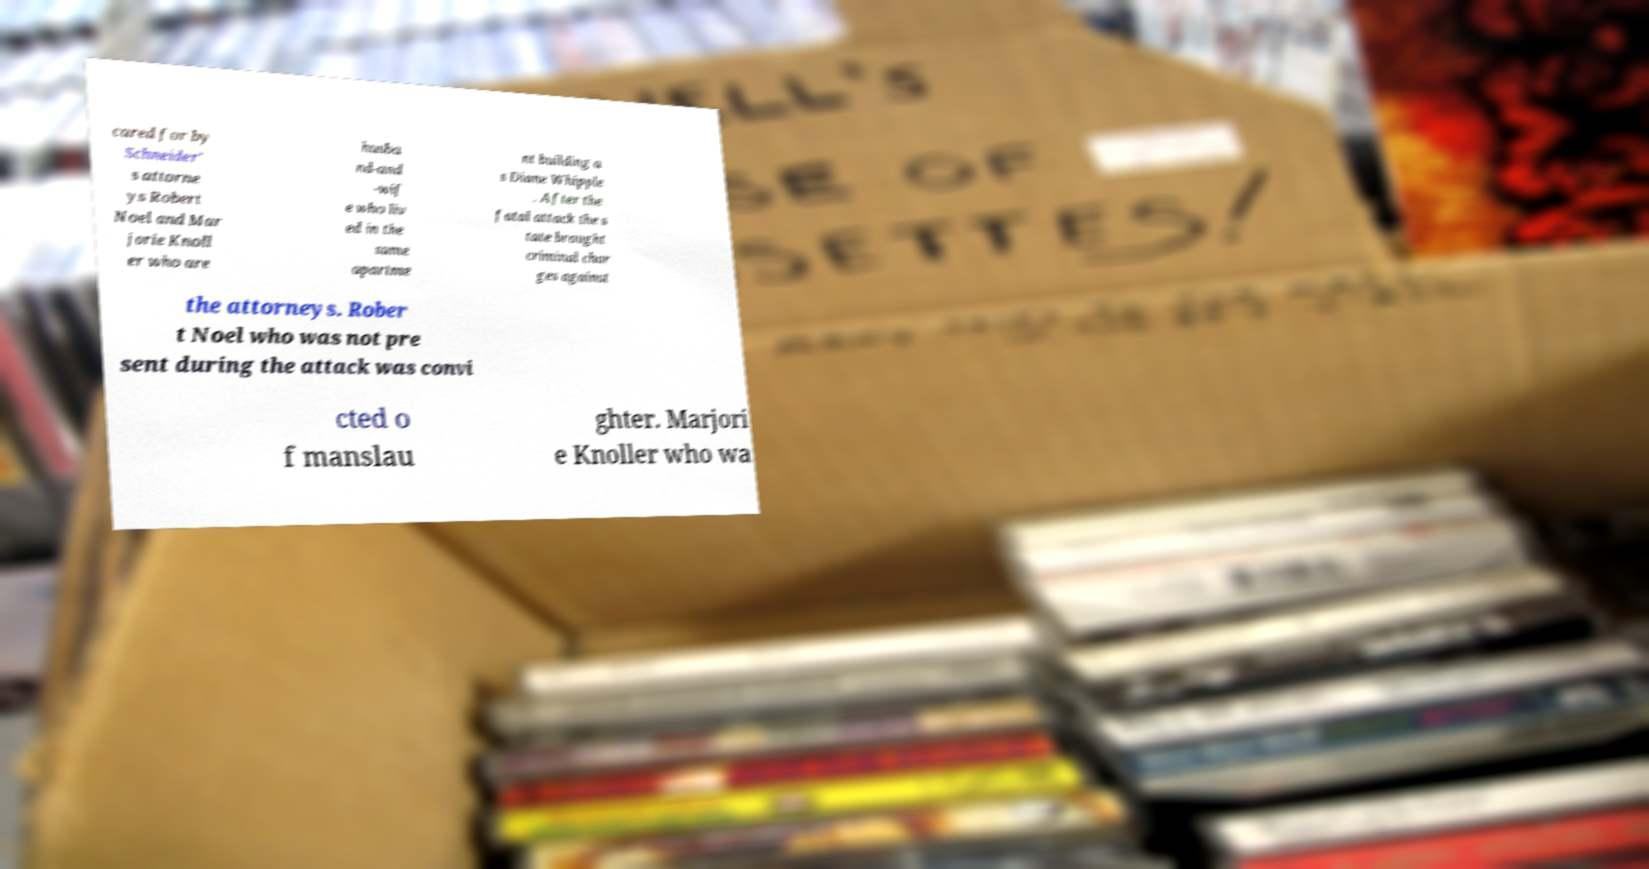For documentation purposes, I need the text within this image transcribed. Could you provide that? cared for by Schneider' s attorne ys Robert Noel and Mar jorie Knoll er who are husba nd-and -wif e who liv ed in the same apartme nt building a s Diane Whipple . After the fatal attack the s tate brought criminal char ges against the attorneys. Rober t Noel who was not pre sent during the attack was convi cted o f manslau ghter. Marjori e Knoller who wa 